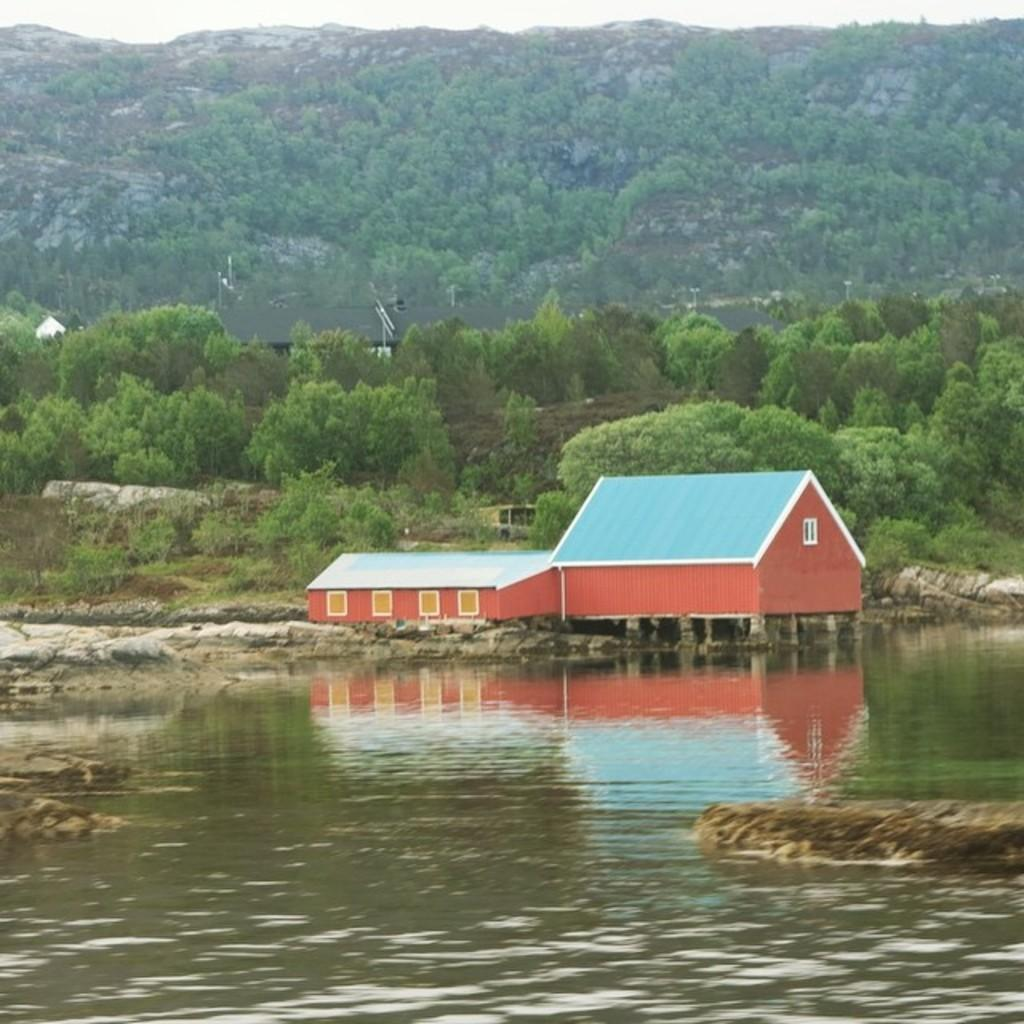What is the primary element visible in the image? There is water in the image. What structure is located behind the water? There is a house behind the water. What type of vegetation is visible behind the house? There are trees behind the house. What type of landscape feature can be seen in the distance? There are mountains visible in the image. What type of verse can be heard recited by the trees in the image? There is no verse being recited by the trees in the image, as trees do not have the ability to speak or recite poetry. 